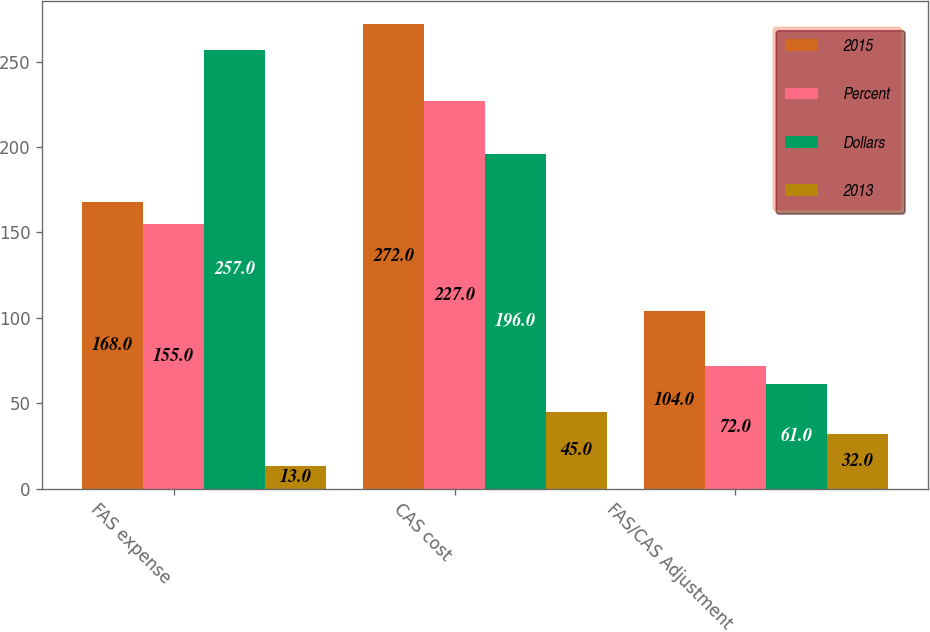<chart> <loc_0><loc_0><loc_500><loc_500><stacked_bar_chart><ecel><fcel>FAS expense<fcel>CAS cost<fcel>FAS/CAS Adjustment<nl><fcel>2015<fcel>168<fcel>272<fcel>104<nl><fcel>Percent<fcel>155<fcel>227<fcel>72<nl><fcel>Dollars<fcel>257<fcel>196<fcel>61<nl><fcel>2013<fcel>13<fcel>45<fcel>32<nl></chart> 